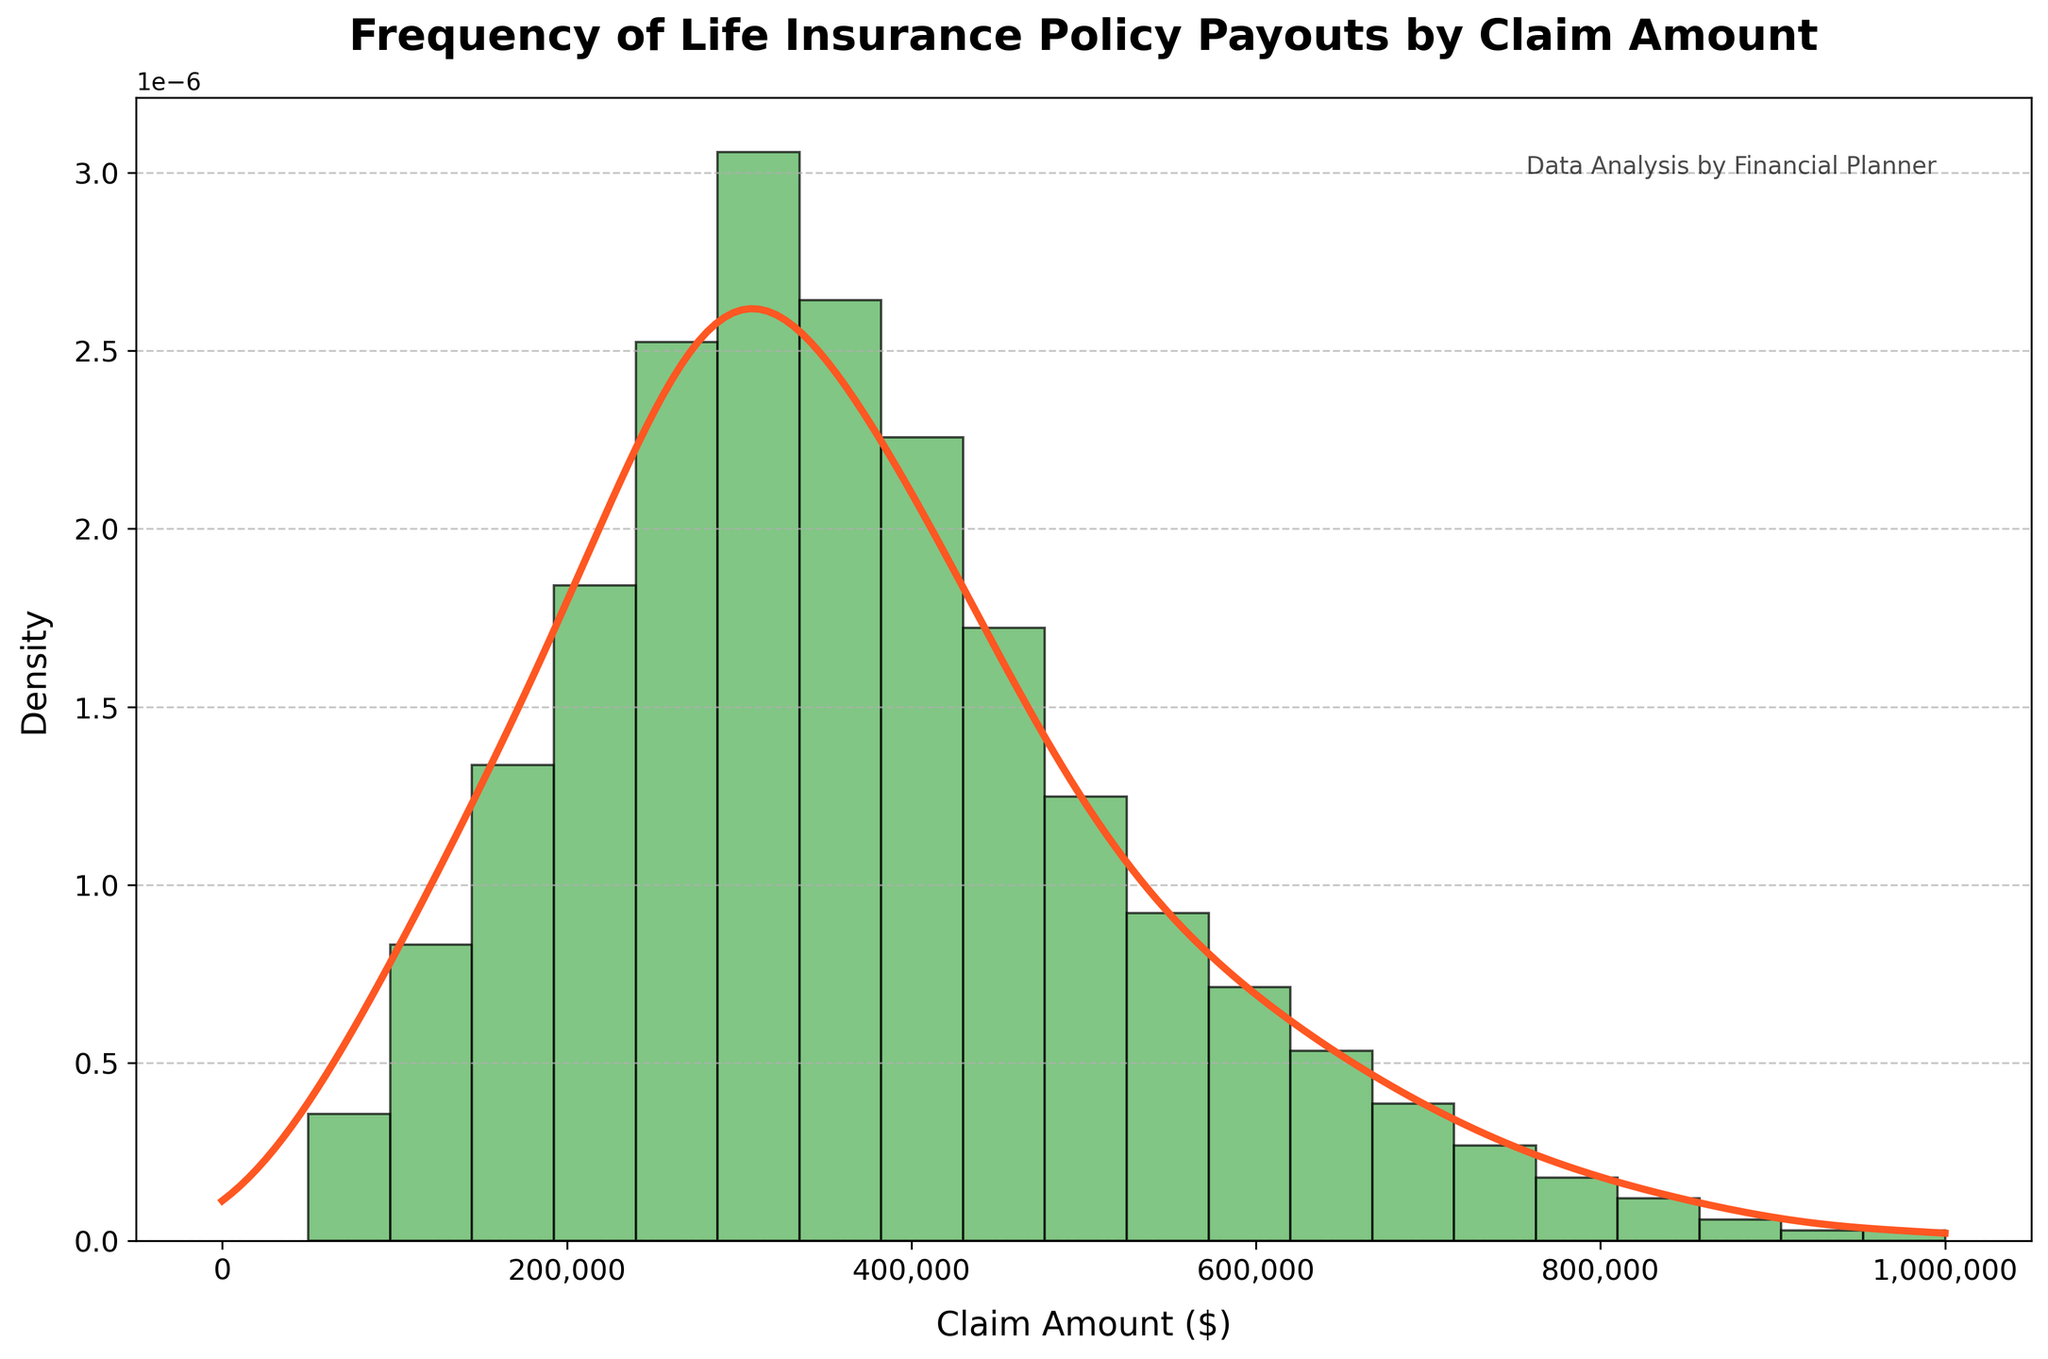What's the title of the plot? The text at the top of the figure reads 'Frequency of Life Insurance Policy Payouts by Claim Amount', indicating it is the title of the plot.
Answer: Frequency of Life Insurance Policy Payouts by Claim Amount What does the x-axis represent? The label along the x-axis reads 'Claim Amount ($)', which refers to the amount of the life insurance payouts.
Answer: Claim Amount ($) What color represents the histogram bars? The histogram bars are filled with a color that matches the description of '#4CAF50', which is a shade of green.
Answer: Green How many histogram bins are there in the figure? By visually counting the vertical bars in the histogram, we can see there are 20 bins.
Answer: 20 Which claim amount has the highest frequency? By looking at the tallest bar in the histogram, we see it corresponds to the claim amount of $300,000.
Answer: $300,000 How does the density curve compare to the histogram at higher claim amounts? The density curve (KDE) follows the histogram but gradually decreases faster after $500,000, reflecting fewer high claim amounts.
Answer: It decreases faster after $500,000 What is the frequency of the claim amount at the peak of the KDE? The peak of the KDE coincides with the tallest histogram bar, so the frequency at the peak is 103 for the $300,000 claim amount.
Answer: 103 Are there more claim amounts above or below $500,000? By observing the histogram, more bars, and hence more claim amounts, are below $500,000 as the frequency significantly drops after $500,000.
Answer: Below $500,000 How does the frequency change as the claim amount increases from $50,000 to $300,000? The frequency increases progressively from 12 at $50,000 to 103 at $300,000, indicating a growing trend.
Answer: It increases Which has a larger density value at $250,000 or $750,000? The density curve is higher at $250,000 than at $750,000 as seen from its peak being closer to $250,000.
Answer: $250,000 